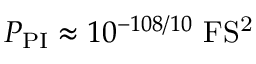Convert formula to latex. <formula><loc_0><loc_0><loc_500><loc_500>P _ { P I } \approx 1 0 ^ { - 1 0 8 / 1 0 } F S ^ { 2 }</formula> 